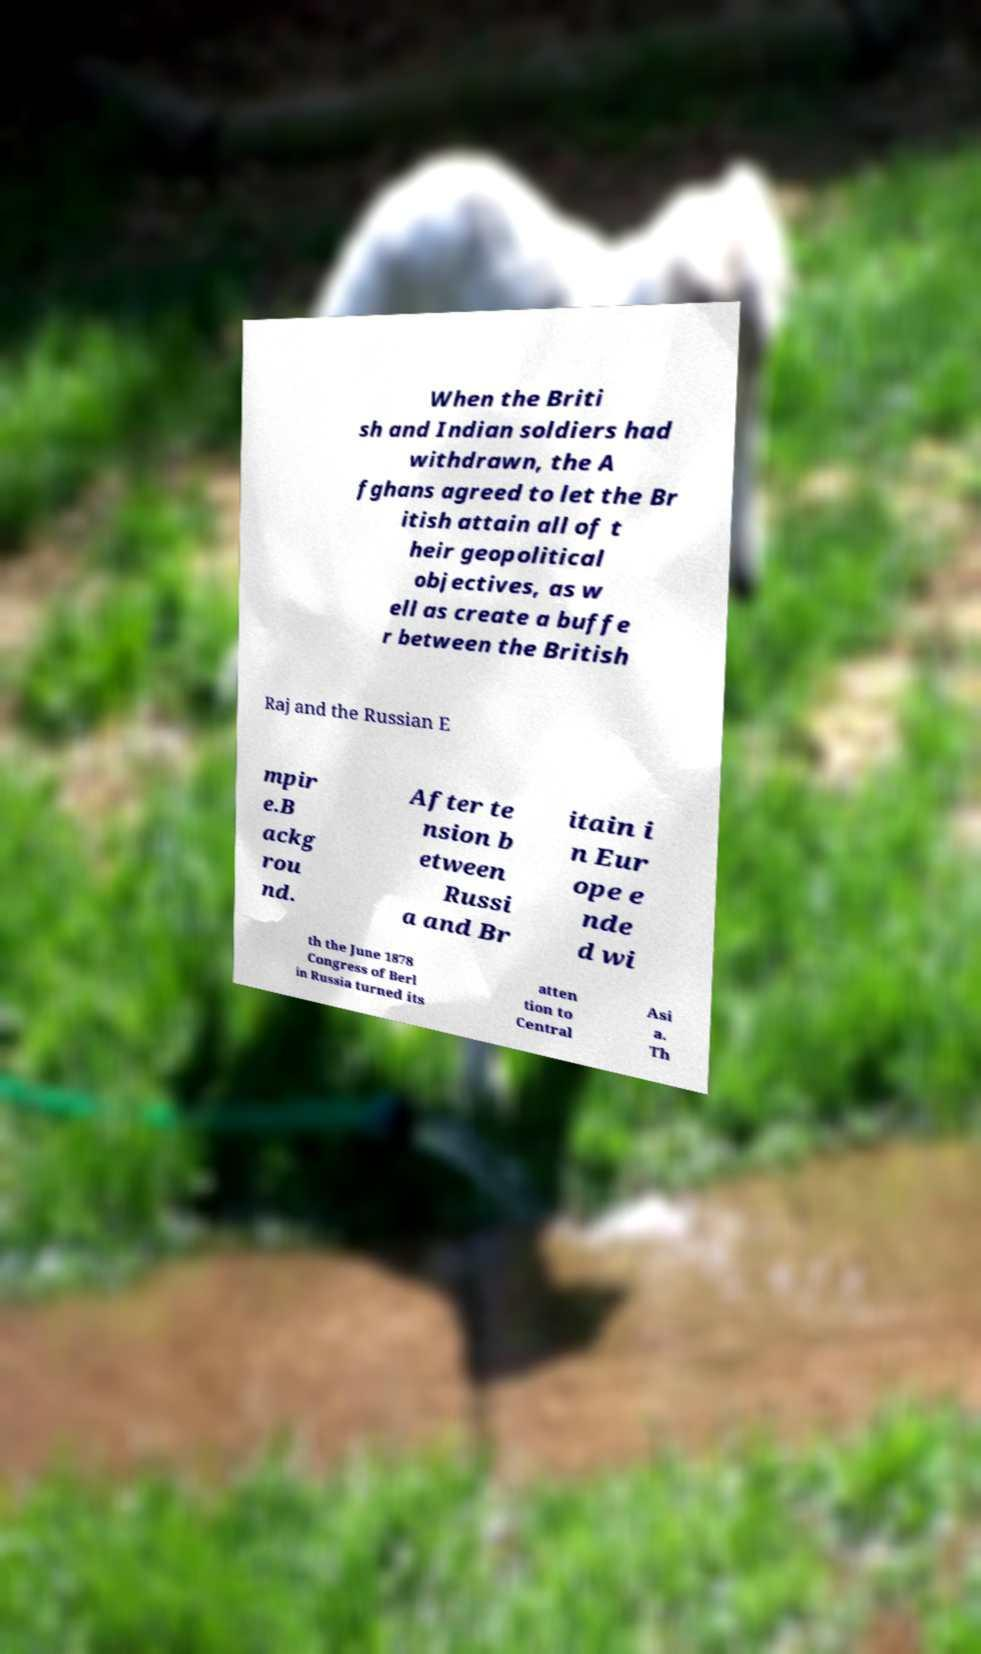Could you assist in decoding the text presented in this image and type it out clearly? When the Briti sh and Indian soldiers had withdrawn, the A fghans agreed to let the Br itish attain all of t heir geopolitical objectives, as w ell as create a buffe r between the British Raj and the Russian E mpir e.B ackg rou nd. After te nsion b etween Russi a and Br itain i n Eur ope e nde d wi th the June 1878 Congress of Berl in Russia turned its atten tion to Central Asi a. Th 